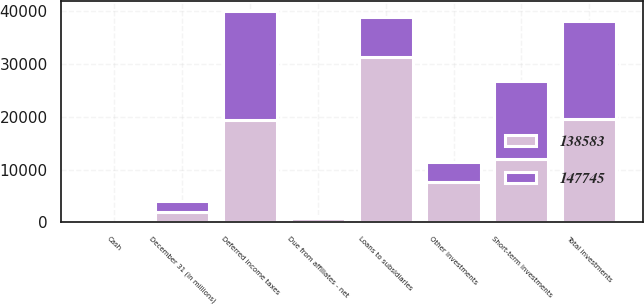Convert chart to OTSL. <chart><loc_0><loc_0><loc_500><loc_500><stacked_bar_chart><ecel><fcel>December 31 (in millions)<fcel>Short-term investments<fcel>Other investments<fcel>Total investments<fcel>Cash<fcel>Loans to subsidiaries<fcel>Due from affiliates - net<fcel>Deferred income taxes<nl><fcel>138583<fcel>2013<fcel>11965<fcel>7561<fcel>19526<fcel>30<fcel>31220<fcel>765<fcel>19352<nl><fcel>147745<fcel>2012<fcel>14764<fcel>3902<fcel>18666<fcel>81<fcel>7561<fcel>422<fcel>20601<nl></chart> 